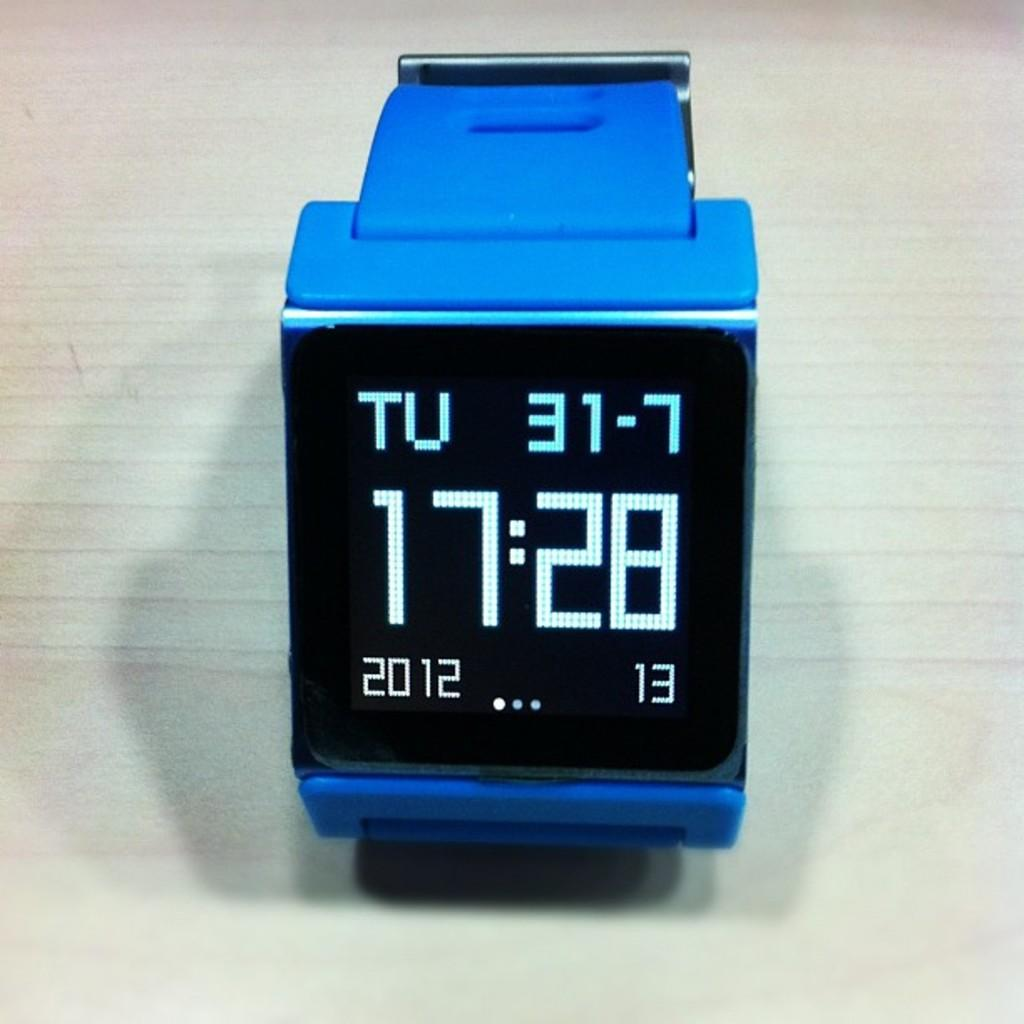<image>
Offer a succinct explanation of the picture presented. a blue watch with a black face stating the time as 17:28 